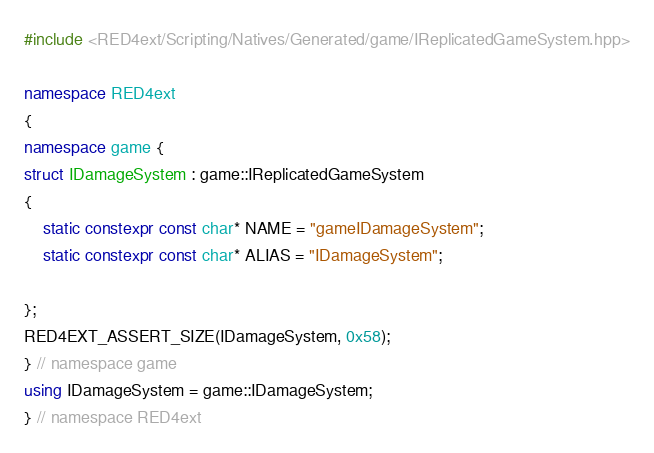Convert code to text. <code><loc_0><loc_0><loc_500><loc_500><_C++_>#include <RED4ext/Scripting/Natives/Generated/game/IReplicatedGameSystem.hpp>

namespace RED4ext
{
namespace game { 
struct IDamageSystem : game::IReplicatedGameSystem
{
    static constexpr const char* NAME = "gameIDamageSystem";
    static constexpr const char* ALIAS = "IDamageSystem";

};
RED4EXT_ASSERT_SIZE(IDamageSystem, 0x58);
} // namespace game
using IDamageSystem = game::IDamageSystem;
} // namespace RED4ext
</code> 